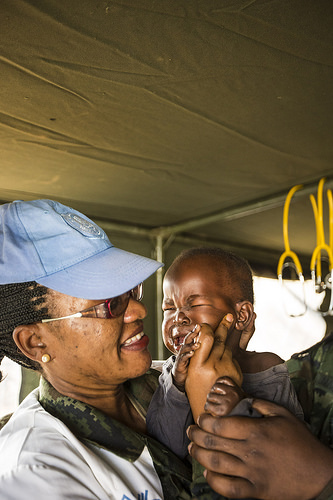<image>
Is there a cap on the head? No. The cap is not positioned on the head. They may be near each other, but the cap is not supported by or resting on top of the head. Is the lady in front of the child? Yes. The lady is positioned in front of the child, appearing closer to the camera viewpoint. 